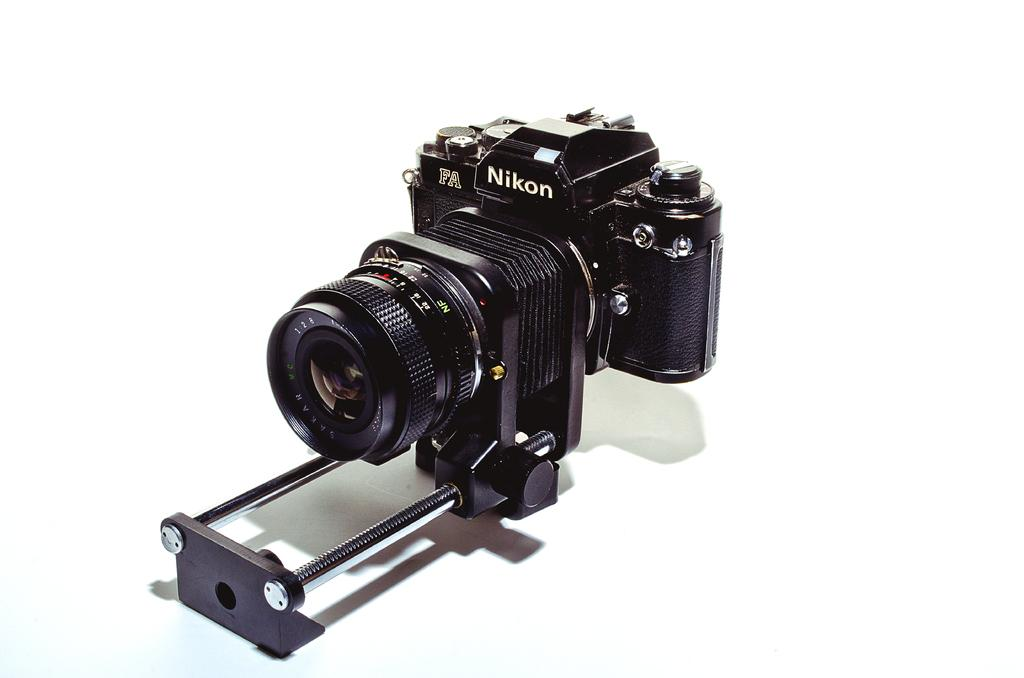What object is the main subject of the picture? The main subject of the picture is a camera. Can you describe the color of the camera? The camera is black in color. How many clouds can be seen in the picture? There are no clouds present in the picture, as it features a camera. What time of day is depicted in the image? The time of day cannot be determined from the image, as it only shows a black camera. 